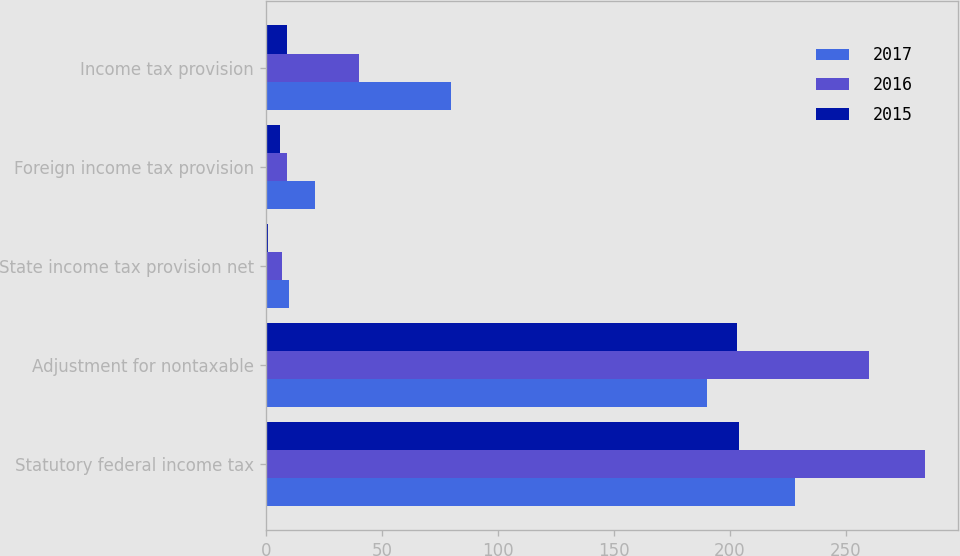<chart> <loc_0><loc_0><loc_500><loc_500><stacked_bar_chart><ecel><fcel>Statutory federal income tax<fcel>Adjustment for nontaxable<fcel>State income tax provision net<fcel>Foreign income tax provision<fcel>Income tax provision<nl><fcel>2017<fcel>228<fcel>190<fcel>10<fcel>21<fcel>80<nl><fcel>2016<fcel>284<fcel>260<fcel>7<fcel>9<fcel>40<nl><fcel>2015<fcel>204<fcel>203<fcel>1<fcel>6<fcel>9<nl></chart> 